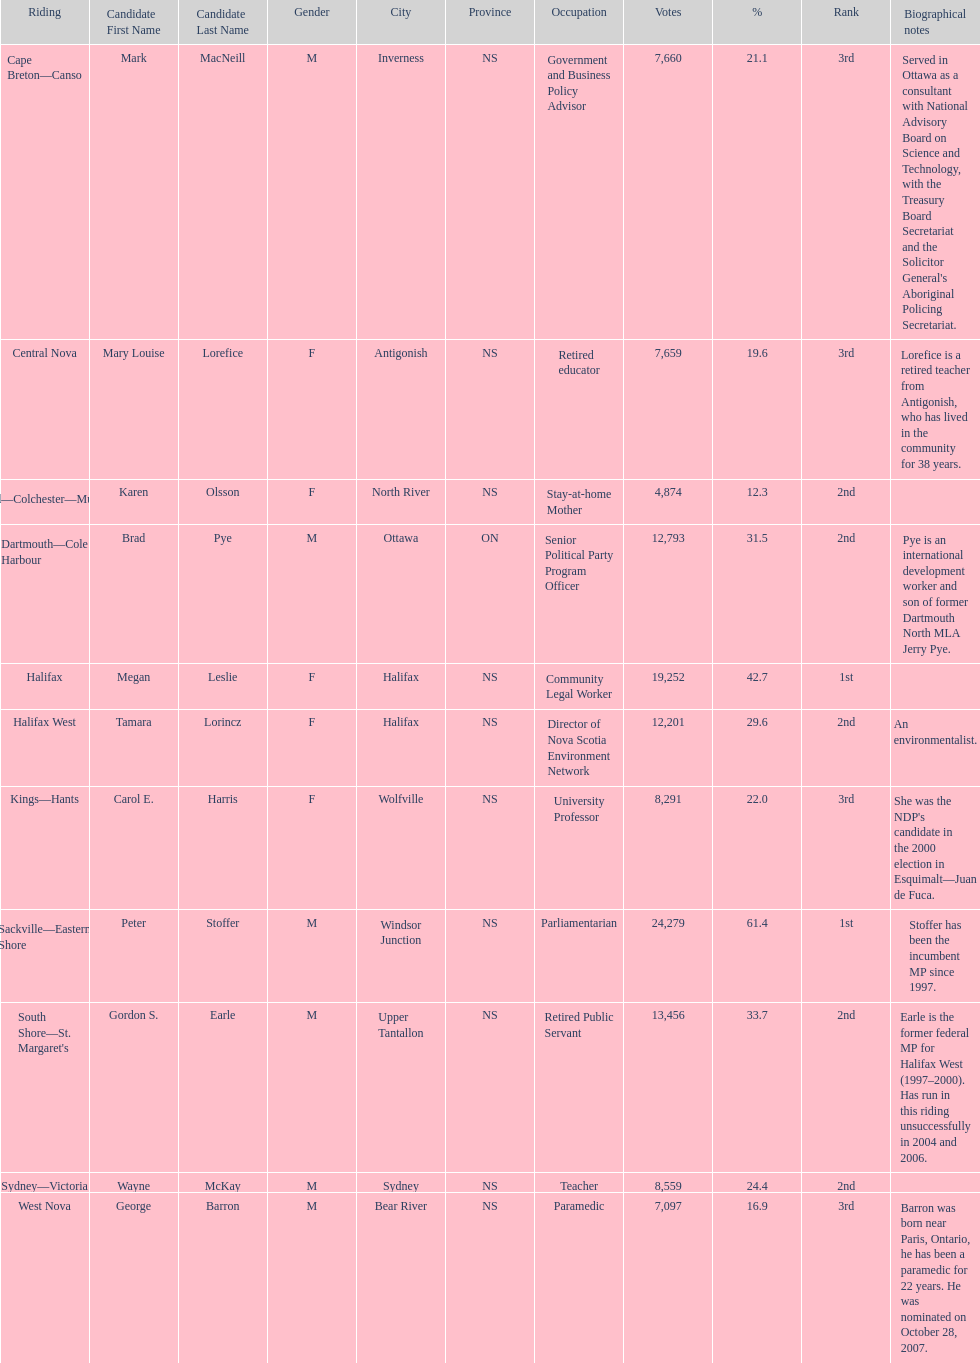How many candidates had more votes than tamara lorincz? 4. 